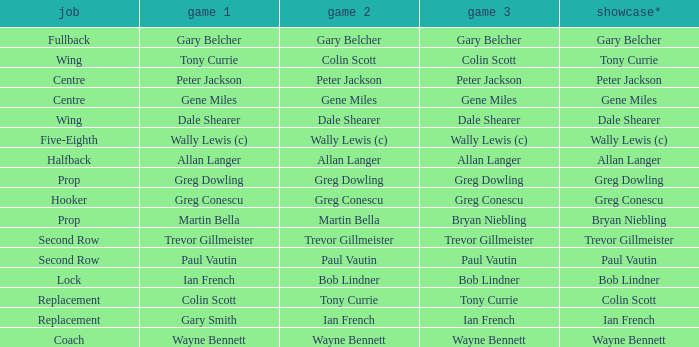What position has colin scott as game 1? Replacement. 